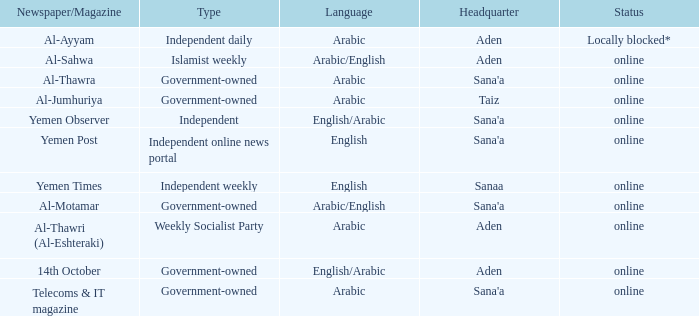What is Headquarter, when Type is Government-Owned, and when Newspaper/Magazine is Al-Jumhuriya? Taiz. 